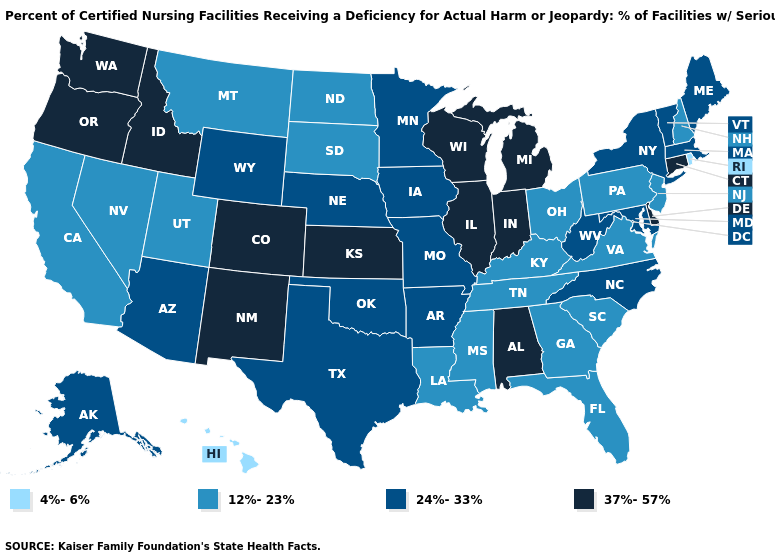What is the value of New Mexico?
Concise answer only. 37%-57%. Does Alabama have the lowest value in the USA?
Keep it brief. No. Name the states that have a value in the range 24%-33%?
Keep it brief. Alaska, Arizona, Arkansas, Iowa, Maine, Maryland, Massachusetts, Minnesota, Missouri, Nebraska, New York, North Carolina, Oklahoma, Texas, Vermont, West Virginia, Wyoming. Among the states that border Pennsylvania , which have the lowest value?
Give a very brief answer. New Jersey, Ohio. What is the highest value in states that border Rhode Island?
Quick response, please. 37%-57%. What is the lowest value in the South?
Give a very brief answer. 12%-23%. What is the lowest value in the Northeast?
Short answer required. 4%-6%. Name the states that have a value in the range 37%-57%?
Concise answer only. Alabama, Colorado, Connecticut, Delaware, Idaho, Illinois, Indiana, Kansas, Michigan, New Mexico, Oregon, Washington, Wisconsin. What is the lowest value in the USA?
Give a very brief answer. 4%-6%. Which states have the lowest value in the USA?
Answer briefly. Hawaii, Rhode Island. Name the states that have a value in the range 12%-23%?
Answer briefly. California, Florida, Georgia, Kentucky, Louisiana, Mississippi, Montana, Nevada, New Hampshire, New Jersey, North Dakota, Ohio, Pennsylvania, South Carolina, South Dakota, Tennessee, Utah, Virginia. What is the lowest value in the Northeast?
Concise answer only. 4%-6%. Which states have the lowest value in the South?
Write a very short answer. Florida, Georgia, Kentucky, Louisiana, Mississippi, South Carolina, Tennessee, Virginia. Which states hav the highest value in the Northeast?
Concise answer only. Connecticut. What is the value of Arizona?
Be succinct. 24%-33%. 